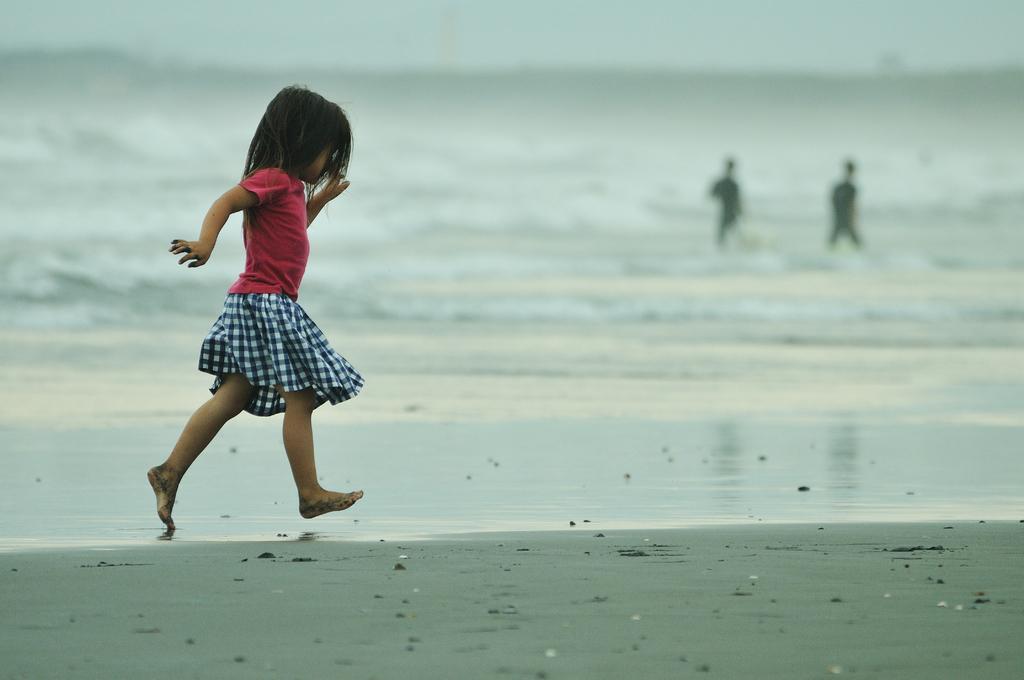Could you give a brief overview of what you see in this image? In this picture we can see a girl running on sand, two people, water and in the background we can see the sky. 